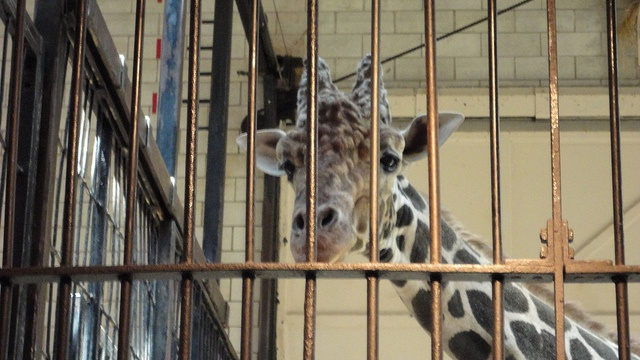Describe the objects in this image and their specific colors. I can see a giraffe in black, gray, and darkgray tones in this image. 